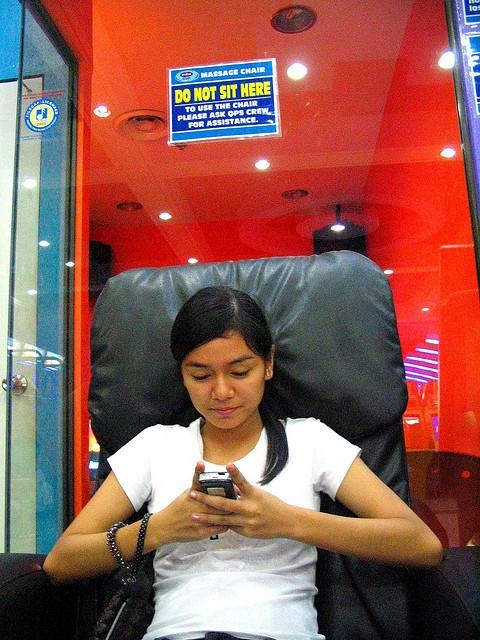What service is this lady receiving? Please explain your reasoning. massage. The sign above the chair indicates its purpose. 